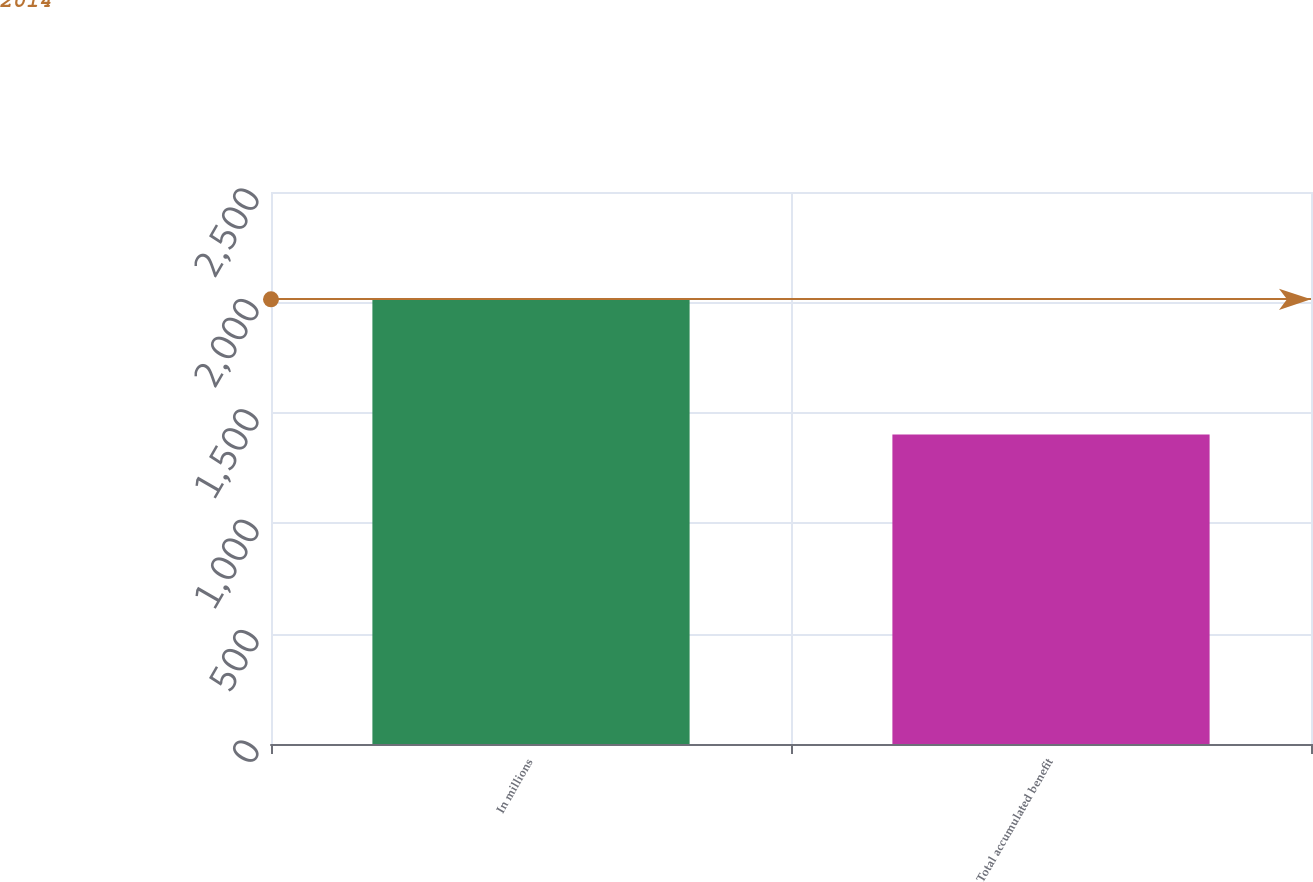Convert chart to OTSL. <chart><loc_0><loc_0><loc_500><loc_500><bar_chart><fcel>In millions<fcel>Total accumulated benefit<nl><fcel>2014<fcel>1402<nl></chart> 